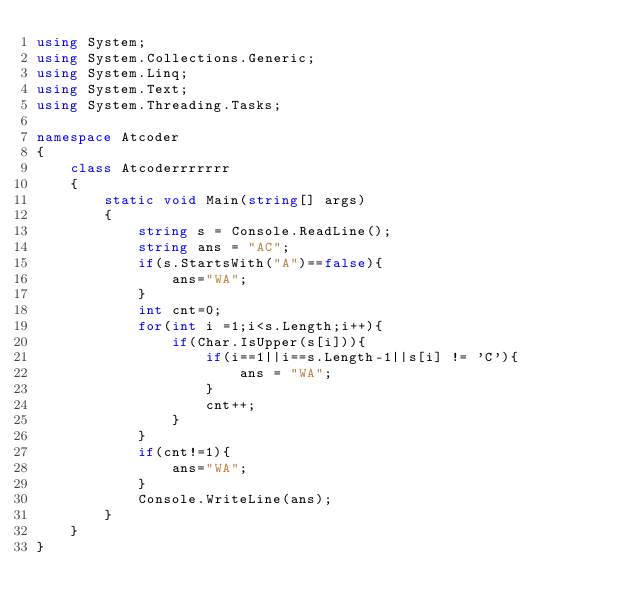Convert code to text. <code><loc_0><loc_0><loc_500><loc_500><_C#_>using System;
using System.Collections.Generic;
using System.Linq;
using System.Text;
using System.Threading.Tasks;

namespace Atcoder
{
    class Atcoderrrrrrr
    {
        static void Main(string[] args)
        {
            string s = Console.ReadLine();
            string ans = "AC";
            if(s.StartsWith("A")==false){
                ans="WA";
            }
            int cnt=0;
            for(int i =1;i<s.Length;i++){
                if(Char.IsUpper(s[i])){
                    if(i==1||i==s.Length-1||s[i] != 'C'){
                        ans = "WA";
                    }
                    cnt++;
                }
            }
            if(cnt!=1){
                ans="WA";
            }
            Console.WriteLine(ans);
        }
    }
}
</code> 